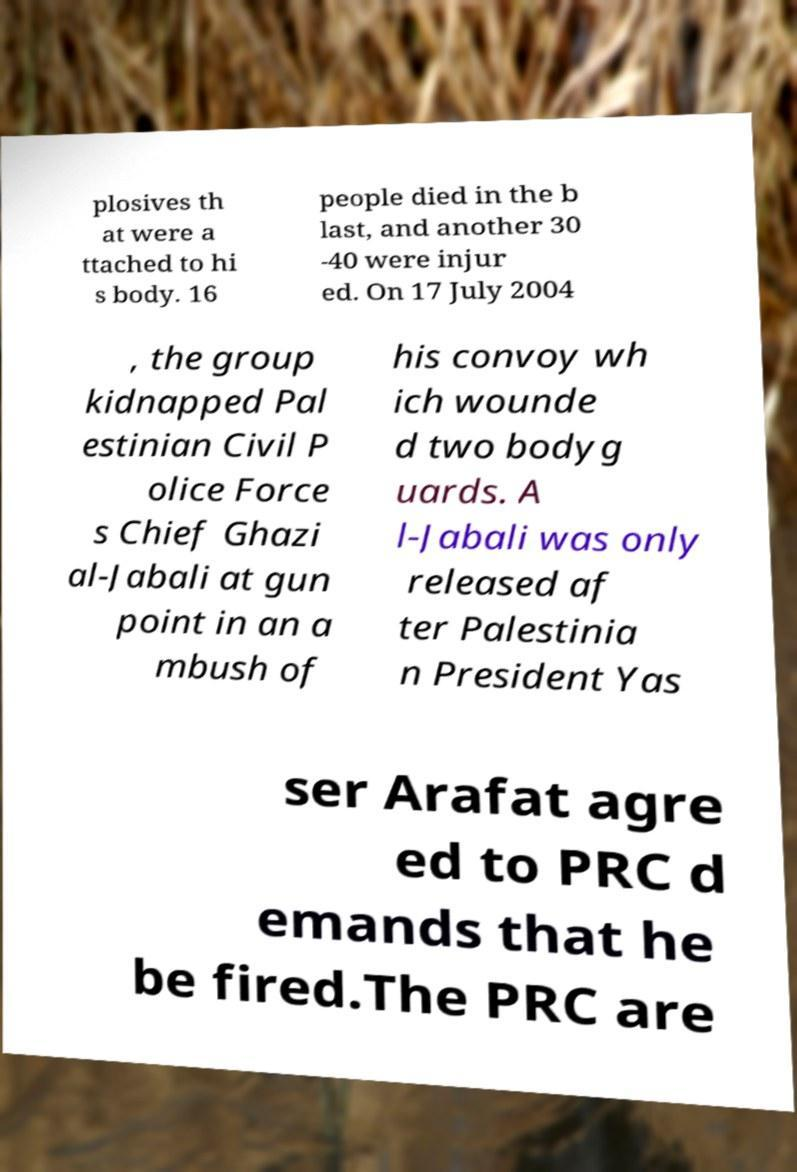What messages or text are displayed in this image? I need them in a readable, typed format. plosives th at were a ttached to hi s body. 16 people died in the b last, and another 30 -40 were injur ed. On 17 July 2004 , the group kidnapped Pal estinian Civil P olice Force s Chief Ghazi al-Jabali at gun point in an a mbush of his convoy wh ich wounde d two bodyg uards. A l-Jabali was only released af ter Palestinia n President Yas ser Arafat agre ed to PRC d emands that he be fired.The PRC are 